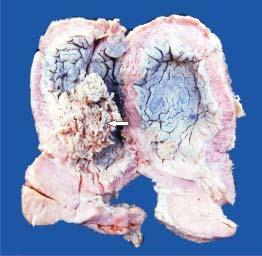does the pink acellular amyloid material show papillary tumour floating in the lumen?
Answer the question using a single word or phrase. No 